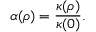Convert formula to latex. <formula><loc_0><loc_0><loc_500><loc_500>\alpha ( \rho ) = \frac { \kappa ( \rho ) } { \kappa ( 0 ) } .</formula> 